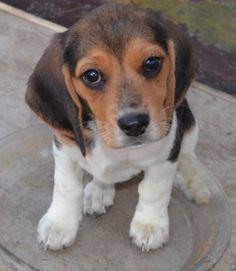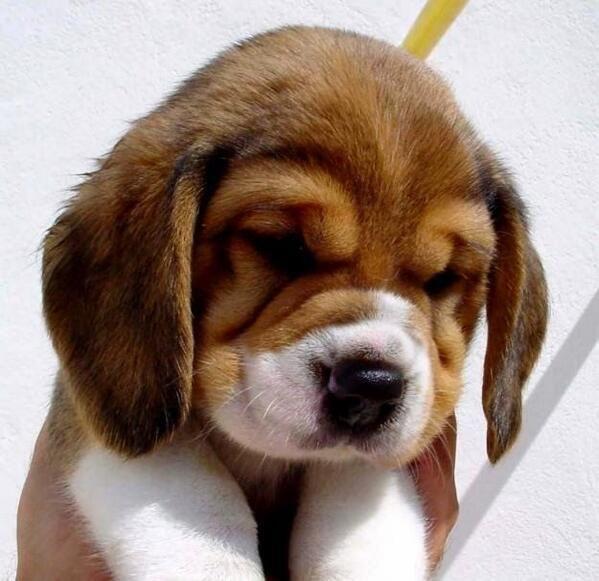The first image is the image on the left, the second image is the image on the right. Assess this claim about the two images: "The dog in the image on the right has a predominately black head.". Correct or not? Answer yes or no. No. 